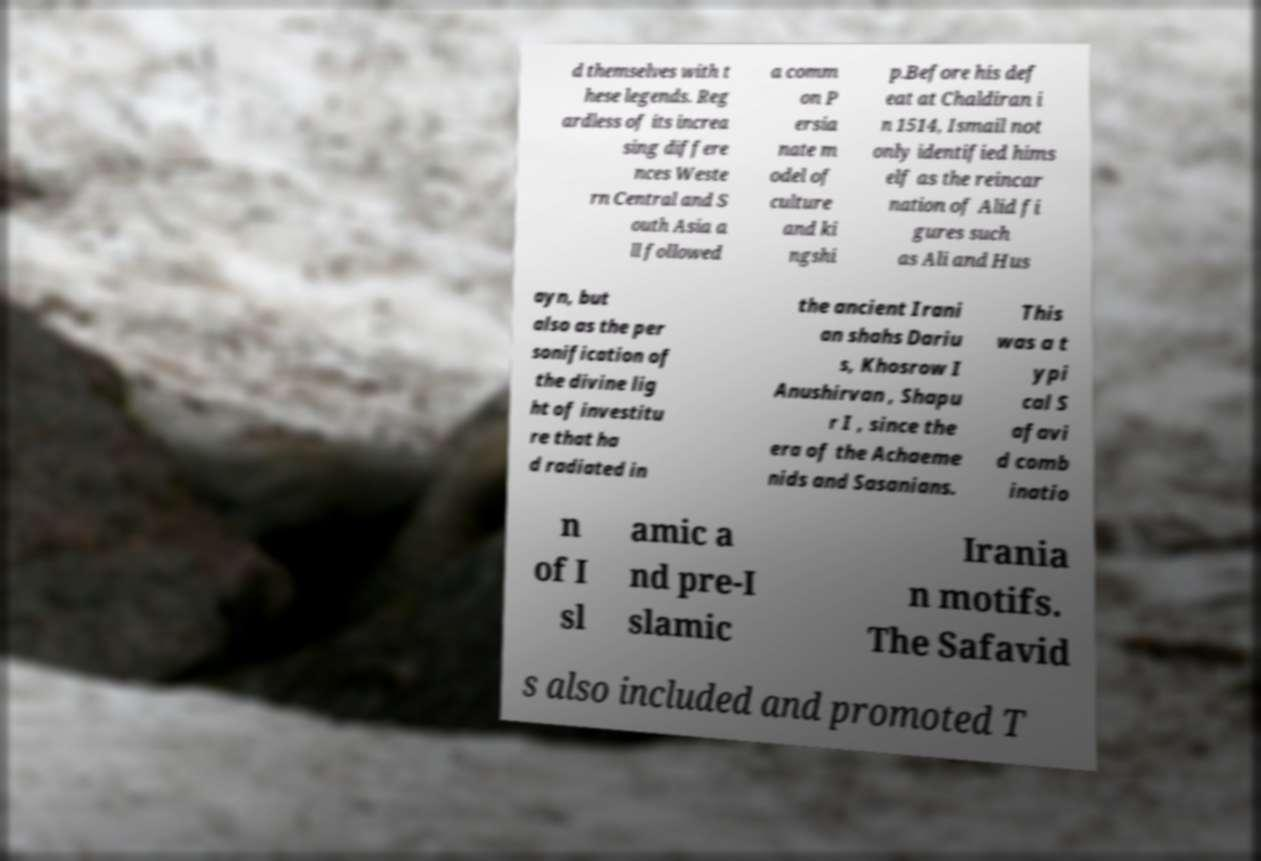I need the written content from this picture converted into text. Can you do that? d themselves with t hese legends. Reg ardless of its increa sing differe nces Weste rn Central and S outh Asia a ll followed a comm on P ersia nate m odel of culture and ki ngshi p.Before his def eat at Chaldiran i n 1514, Ismail not only identified hims elf as the reincar nation of Alid fi gures such as Ali and Hus ayn, but also as the per sonification of the divine lig ht of investitu re that ha d radiated in the ancient Irani an shahs Dariu s, Khosrow I Anushirvan , Shapu r I , since the era of the Achaeme nids and Sasanians. This was a t ypi cal S afavi d comb inatio n of I sl amic a nd pre-I slamic Irania n motifs. The Safavid s also included and promoted T 